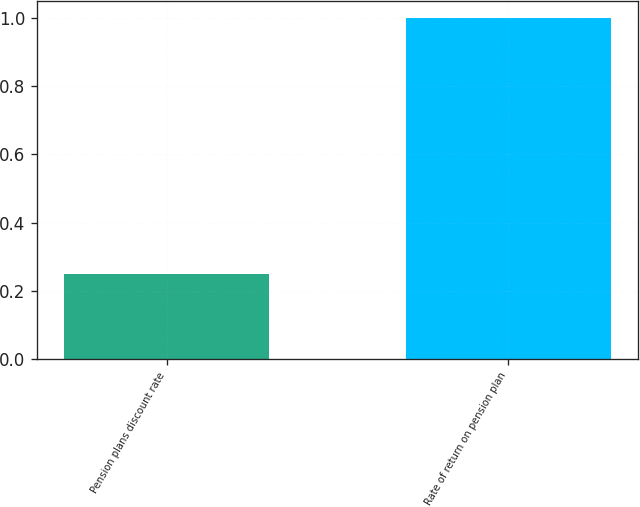<chart> <loc_0><loc_0><loc_500><loc_500><bar_chart><fcel>Pension plans discount rate<fcel>Rate of return on pension plan<nl><fcel>0.25<fcel>1<nl></chart> 